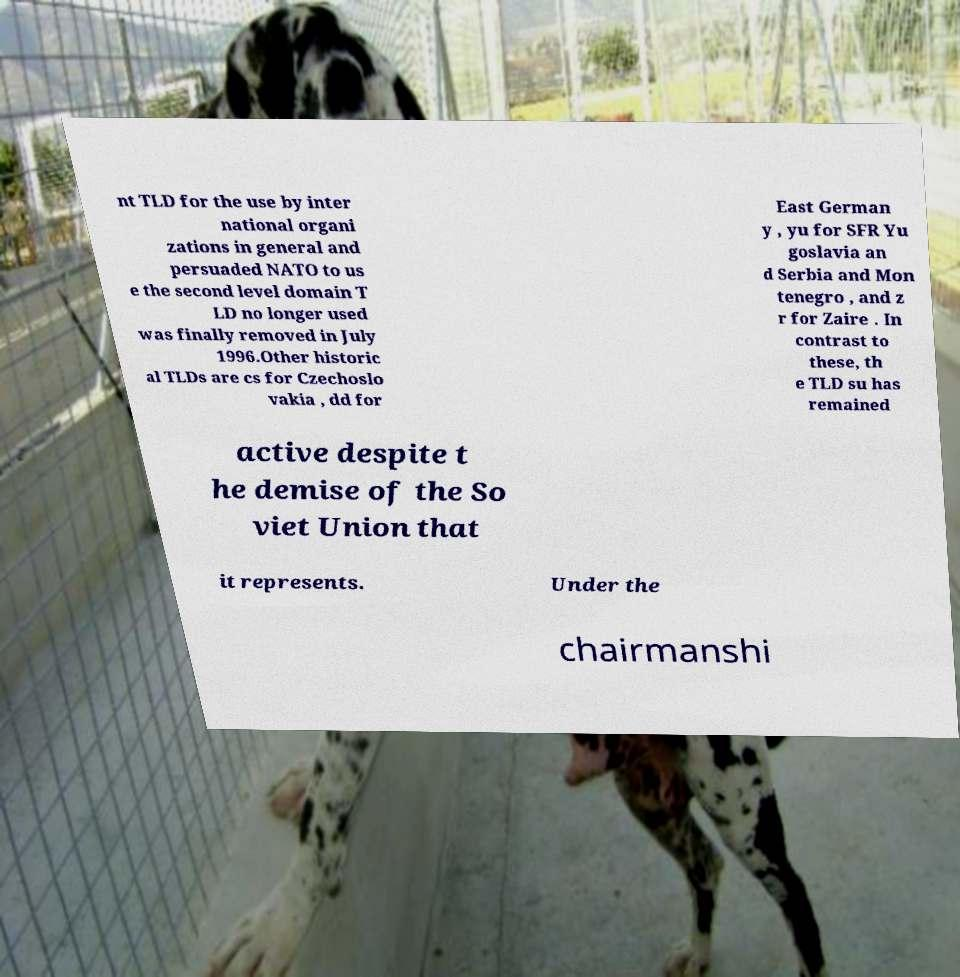I need the written content from this picture converted into text. Can you do that? nt TLD for the use by inter national organi zations in general and persuaded NATO to us e the second level domain T LD no longer used was finally removed in July 1996.Other historic al TLDs are cs for Czechoslo vakia , dd for East German y , yu for SFR Yu goslavia an d Serbia and Mon tenegro , and z r for Zaire . In contrast to these, th e TLD su has remained active despite t he demise of the So viet Union that it represents. Under the chairmanshi 